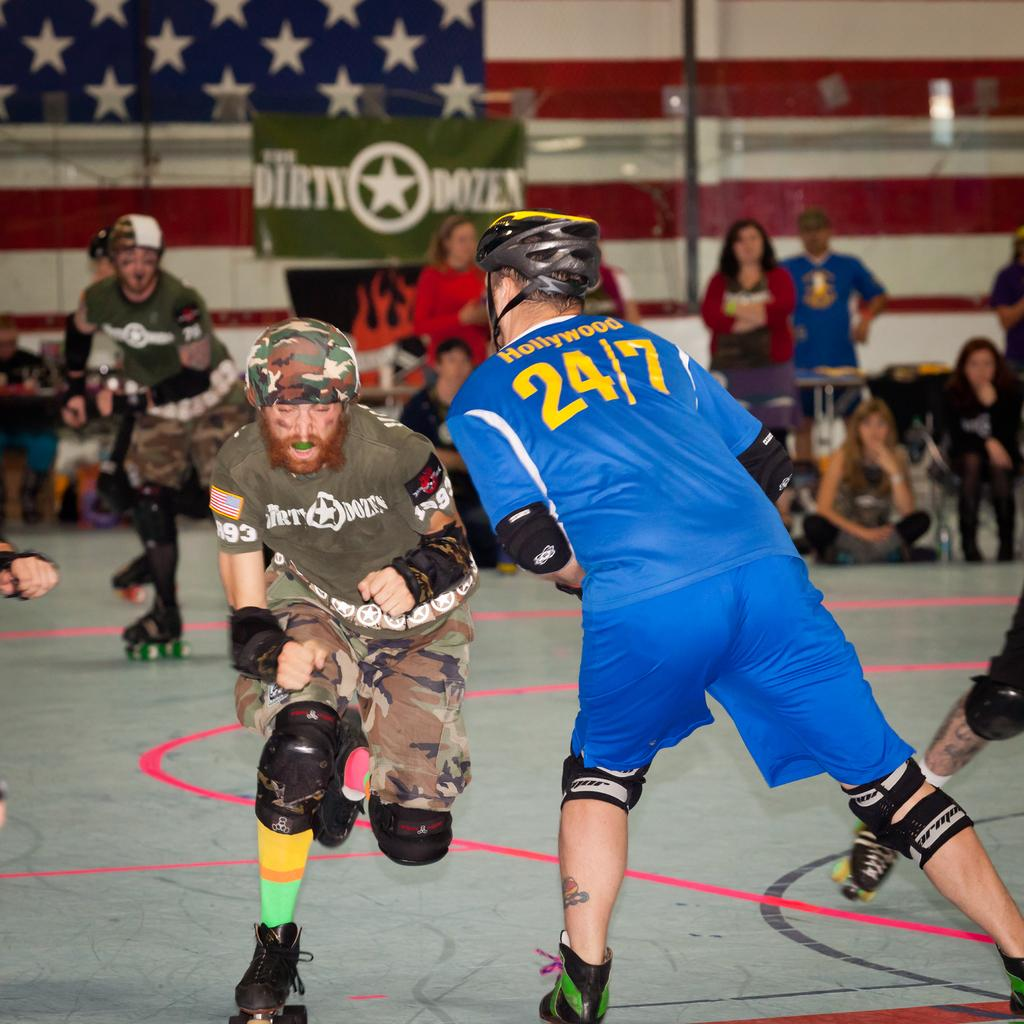What are the persons in the image doing? The persons in the image are skating on the floor. How can we differentiate the dresses of the persons skating? The persons are wearing different color dresses. What can be observed in the background of the image? In the background, there are persons sitting and standing, as well as a banner and a wall. Can you tell me which appliance the pig is using in the image? There is no pig or appliance present in the image. 